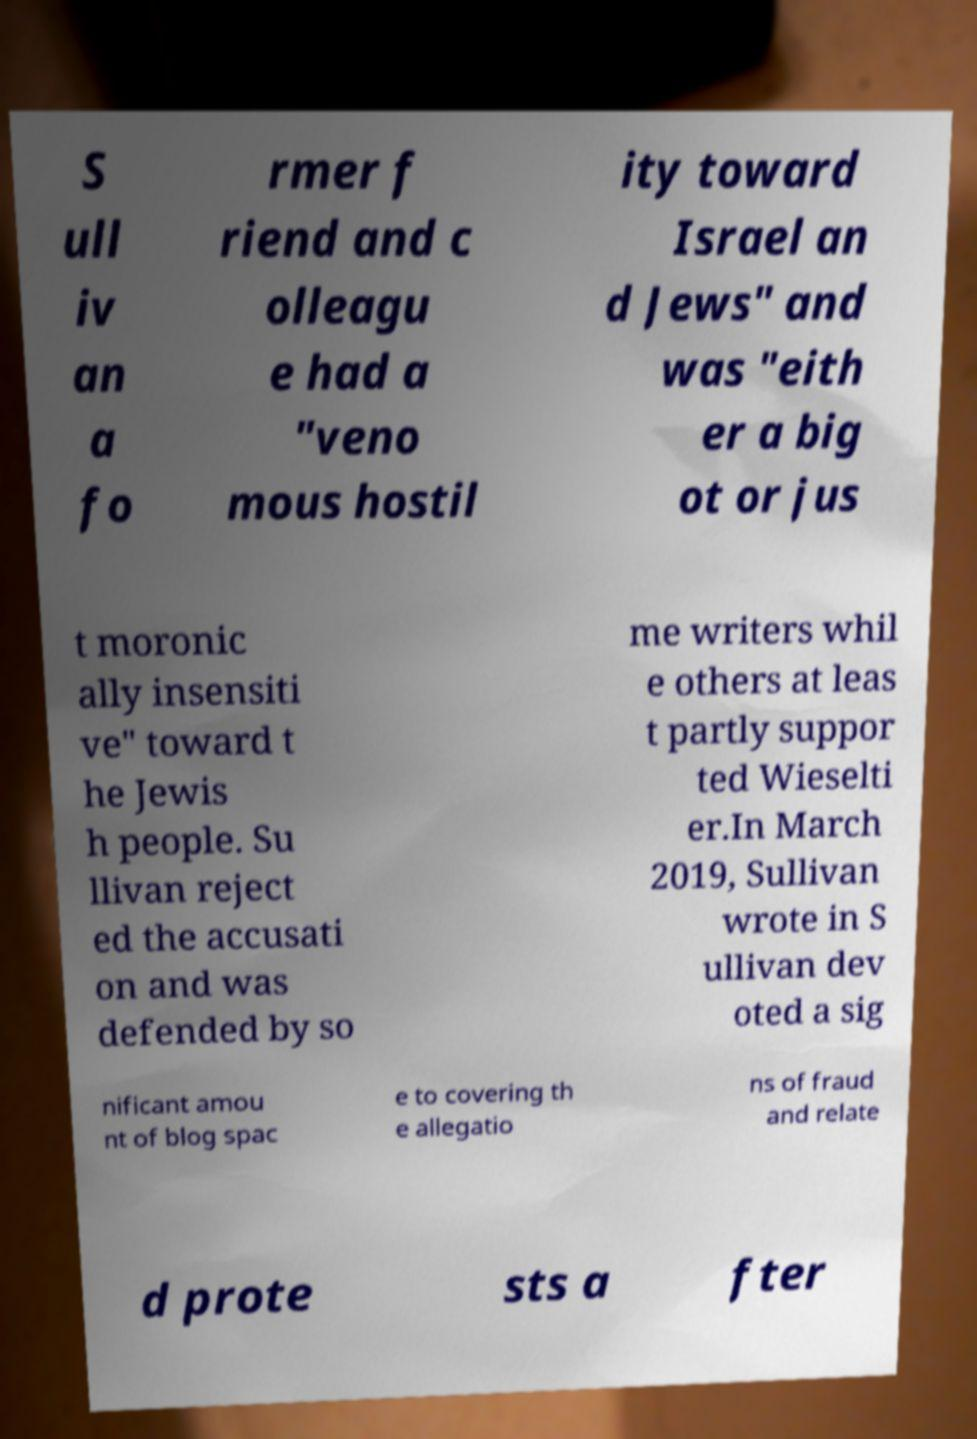What messages or text are displayed in this image? I need them in a readable, typed format. S ull iv an a fo rmer f riend and c olleagu e had a "veno mous hostil ity toward Israel an d Jews" and was "eith er a big ot or jus t moronic ally insensiti ve" toward t he Jewis h people. Su llivan reject ed the accusati on and was defended by so me writers whil e others at leas t partly suppor ted Wieselti er.In March 2019, Sullivan wrote in S ullivan dev oted a sig nificant amou nt of blog spac e to covering th e allegatio ns of fraud and relate d prote sts a fter 